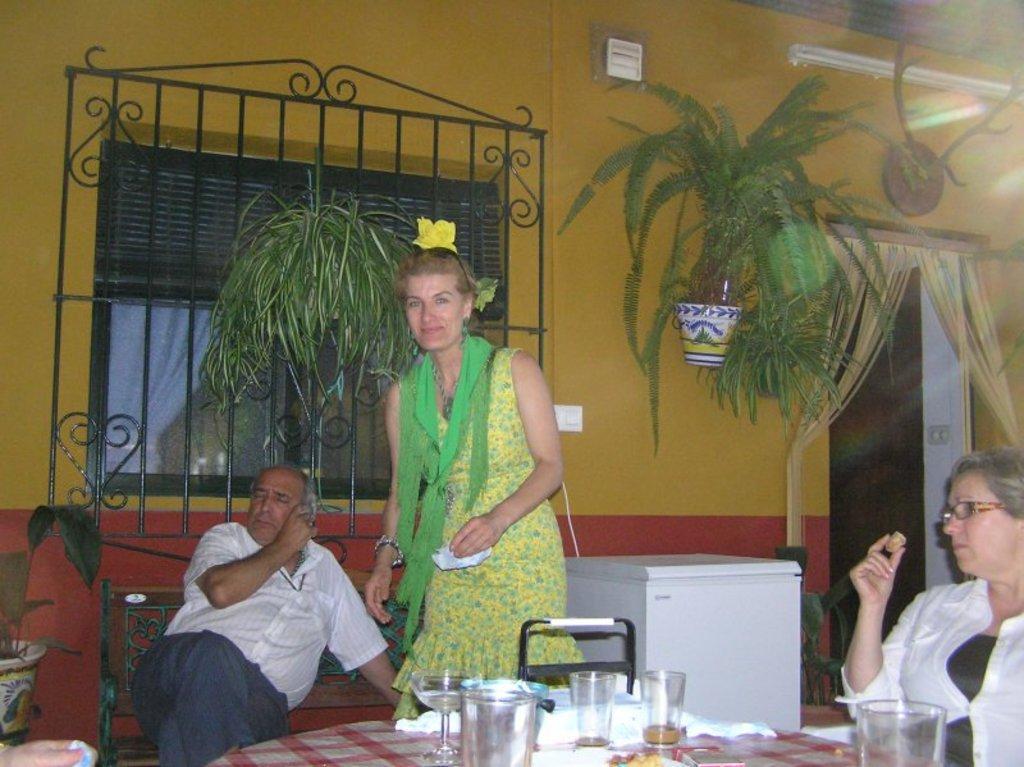In one or two sentences, can you explain what this image depicts? A picture outside of a house. This is window. On wall there is a plant. On top there is a bulb. This woman is standing and holding a paper. This person is sitting on a bench. On this table there are glasses. This woman is sitting on a chair and wore spectacles. This is fridge in white color. Beside this person there is a plant. 